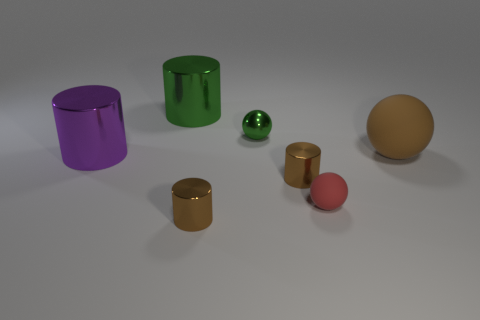Does the green shiny thing that is in front of the large green object have the same size as the cylinder behind the big matte thing?
Keep it short and to the point. No. What number of tiny things are either cyan rubber things or purple shiny things?
Your response must be concise. 0. What number of shiny cylinders are both behind the tiny red rubber thing and to the left of the tiny green sphere?
Provide a succinct answer. 2. Does the small green ball have the same material as the tiny brown thing that is to the left of the tiny green sphere?
Provide a short and direct response. Yes. What number of green things are large cylinders or small metal things?
Make the answer very short. 2. Are there any shiny objects that have the same size as the red ball?
Provide a short and direct response. Yes. There is a green object in front of the shiny thing that is behind the tiny ball behind the large purple object; what is it made of?
Give a very brief answer. Metal. Are there the same number of big brown matte spheres that are behind the small red object and green spheres?
Give a very brief answer. Yes. Do the big cylinder on the right side of the purple shiny object and the sphere in front of the large purple metallic cylinder have the same material?
Provide a succinct answer. No. What number of objects are either green metal spheres or green metallic things that are behind the small green sphere?
Make the answer very short. 2. 